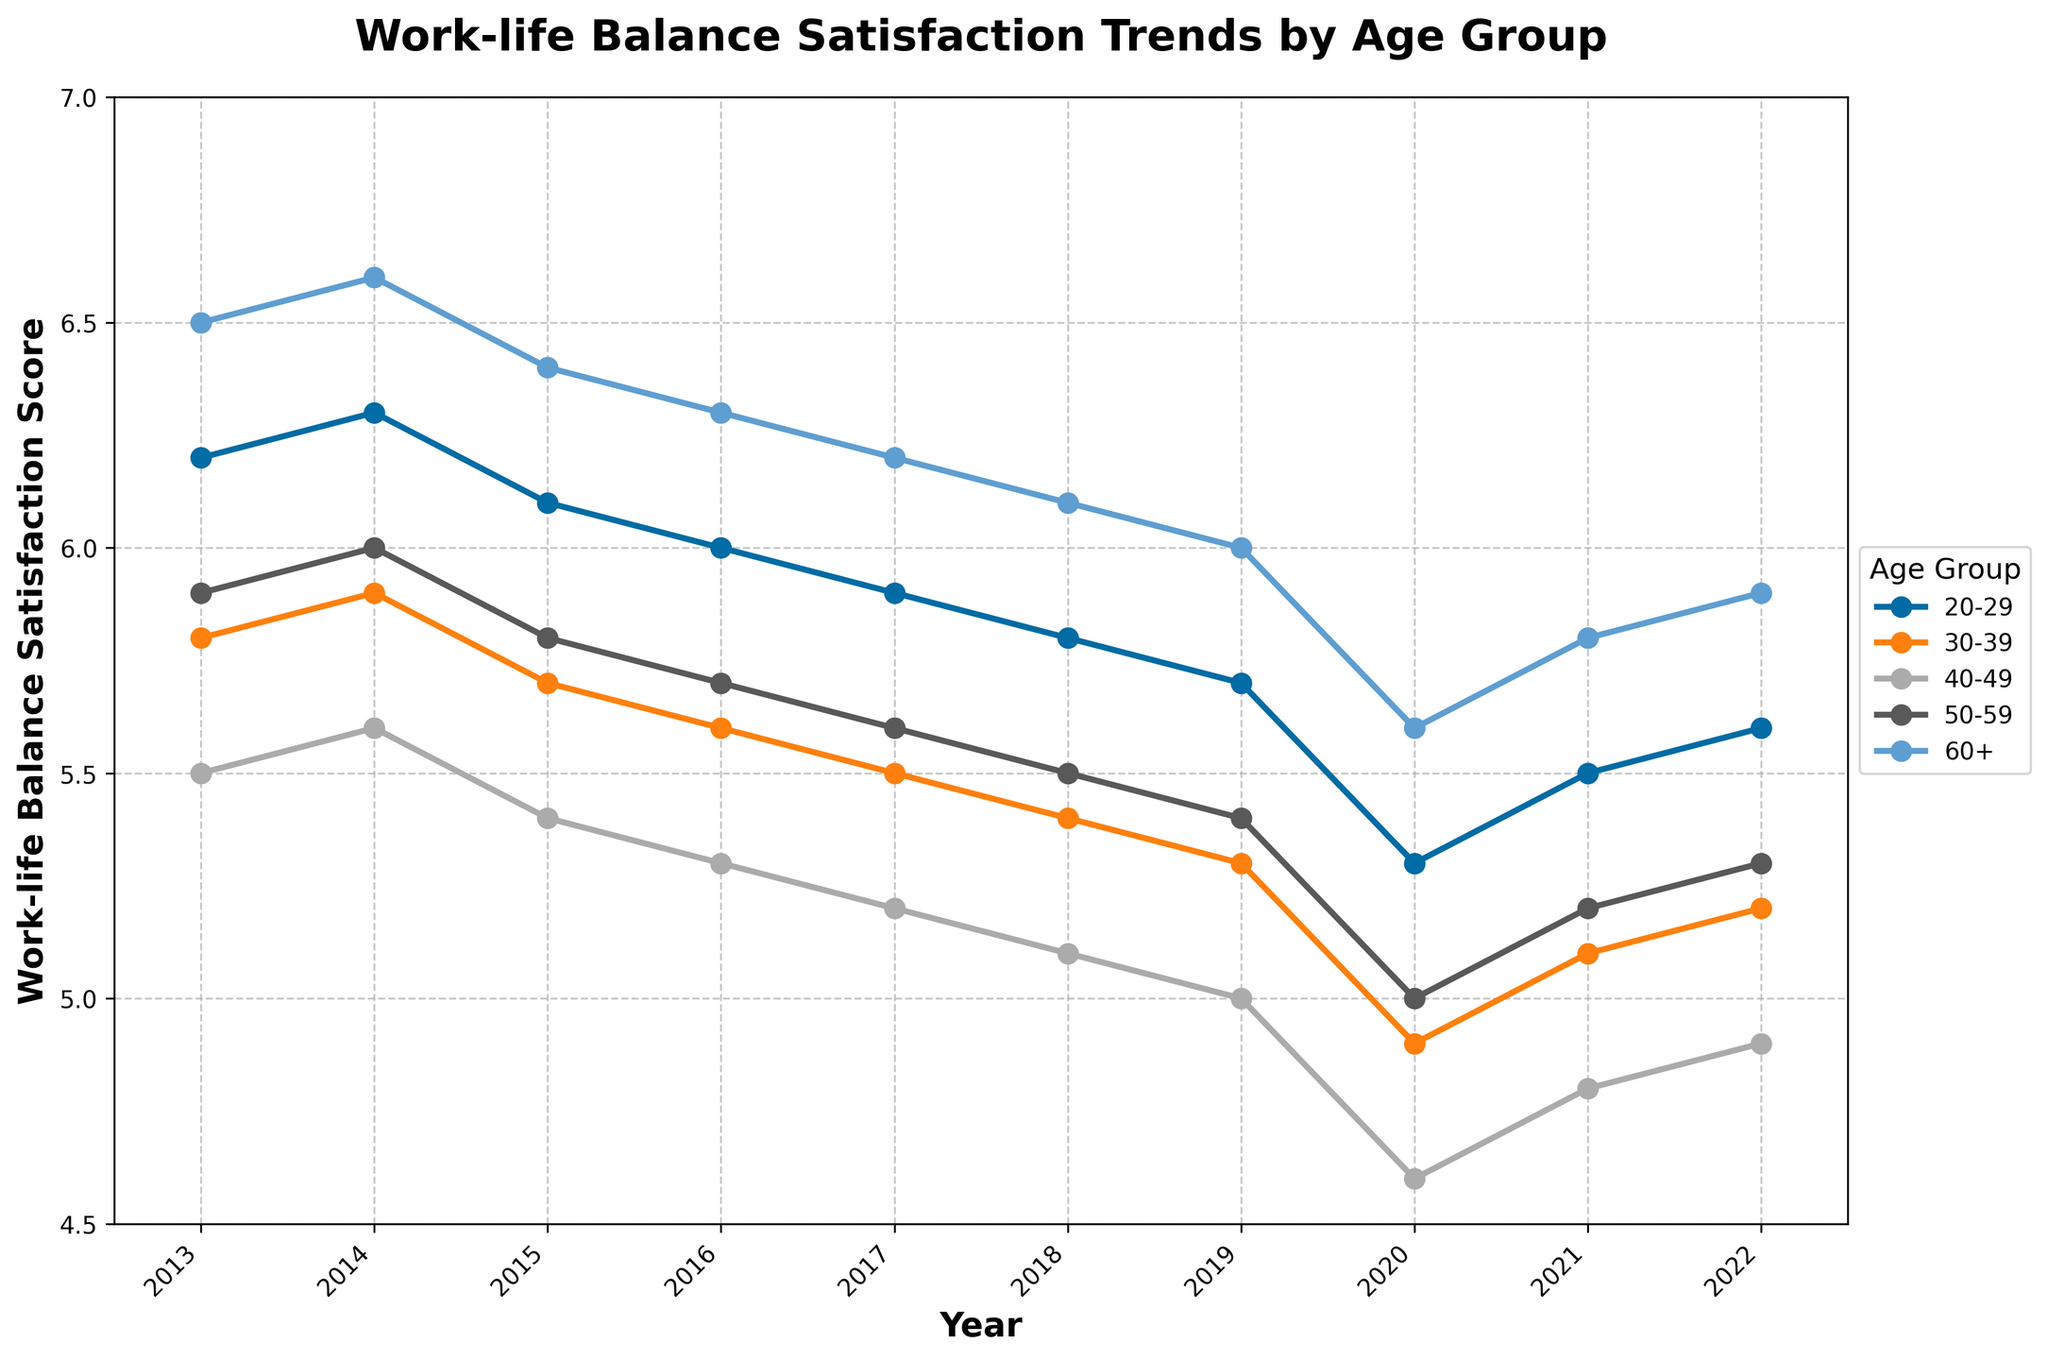Which age group had the highest work-life balance satisfaction score in 2022? Look at the value for each age group in 2022, the group with the highest value is the 60+ age group with a score of 5.9.
Answer: 60+ How did the work-life balance satisfaction score change for age group 30-39 from 2013 to 2020? To find the change, subtract the 2020 value (4.9) from the 2013 value (5.8), resulting in a decrease of 0.9.
Answer: Decreased by 0.9 Which age group saw the greatest decrease in work-life balance satisfaction scores from 2019 to 2020? Identify the difference between 2019 and 2020 values for each age group. The 40-49 age group had the greatest decrease from 5.0 to 4.6, a difference of 0.4.
Answer: 40-49 Which two age groups had the closest work-life balance satisfaction scores in 2018? Compare the scores for 2018 and find the closest values. The age groups 30-39 and 50-59 both had scores of 5.5 and 5.4, respectively, which are very close.
Answer: 30-39 and 50-59 What is the average work-life balance satisfaction score for the age group 20-29 over the 10-year period? Sum the scores from 2013 to 2022 for the 20-29 age group: (6.2 + 6.3 + 6.1 + 6.0 + 5.9 + 5.8 + 5.7 + 5.3 + 5.5 + 5.6) = 58.4, then divide by 10.
Answer: 5.84 Between 2013 and 2022, which age group had the most consistent work-life balance satisfaction scores (least fluctuation)? Examine the range (max - min) of scores for each age group: 20-29 (6.3-5.3=1.0), 30-39 (5.9-4.9=1.0), 40-49 (5.6-4.6=1.0), 50-59 (6.0-5.0=1.0), 60+ (6.6-5.6=1.0). All have the same range.
Answer: All age groups What is the combined work-life balance satisfaction score of the 20-29 and 60+ age groups in 2017? Add the 2017 scores for the 20-29 (5.9) and 60+ (6.2) age groups. 5.9 + 6.2 = 12.1.
Answer: 12.1 By how much did the work-life balance satisfaction score for the 40-49 age group change from 2013 to 2016? Subtract the 2016 score (5.3) from the 2013 score (5.5). 5.5 - 5.3 = 0.2.
Answer: Decreased by 0.2 What is the trend of work-life balance satisfaction scores for the 50-59 age group from 2015 to 2019? Examine the progression from 2015 (5.8), 2016 (5.7), 2017 (5.6), 2018 (5.5), to 2019 (5.4), which shows a continuous decrease each year.
Answer: Decreasing 